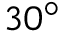<formula> <loc_0><loc_0><loc_500><loc_500>3 0 ^ { \circ }</formula> 